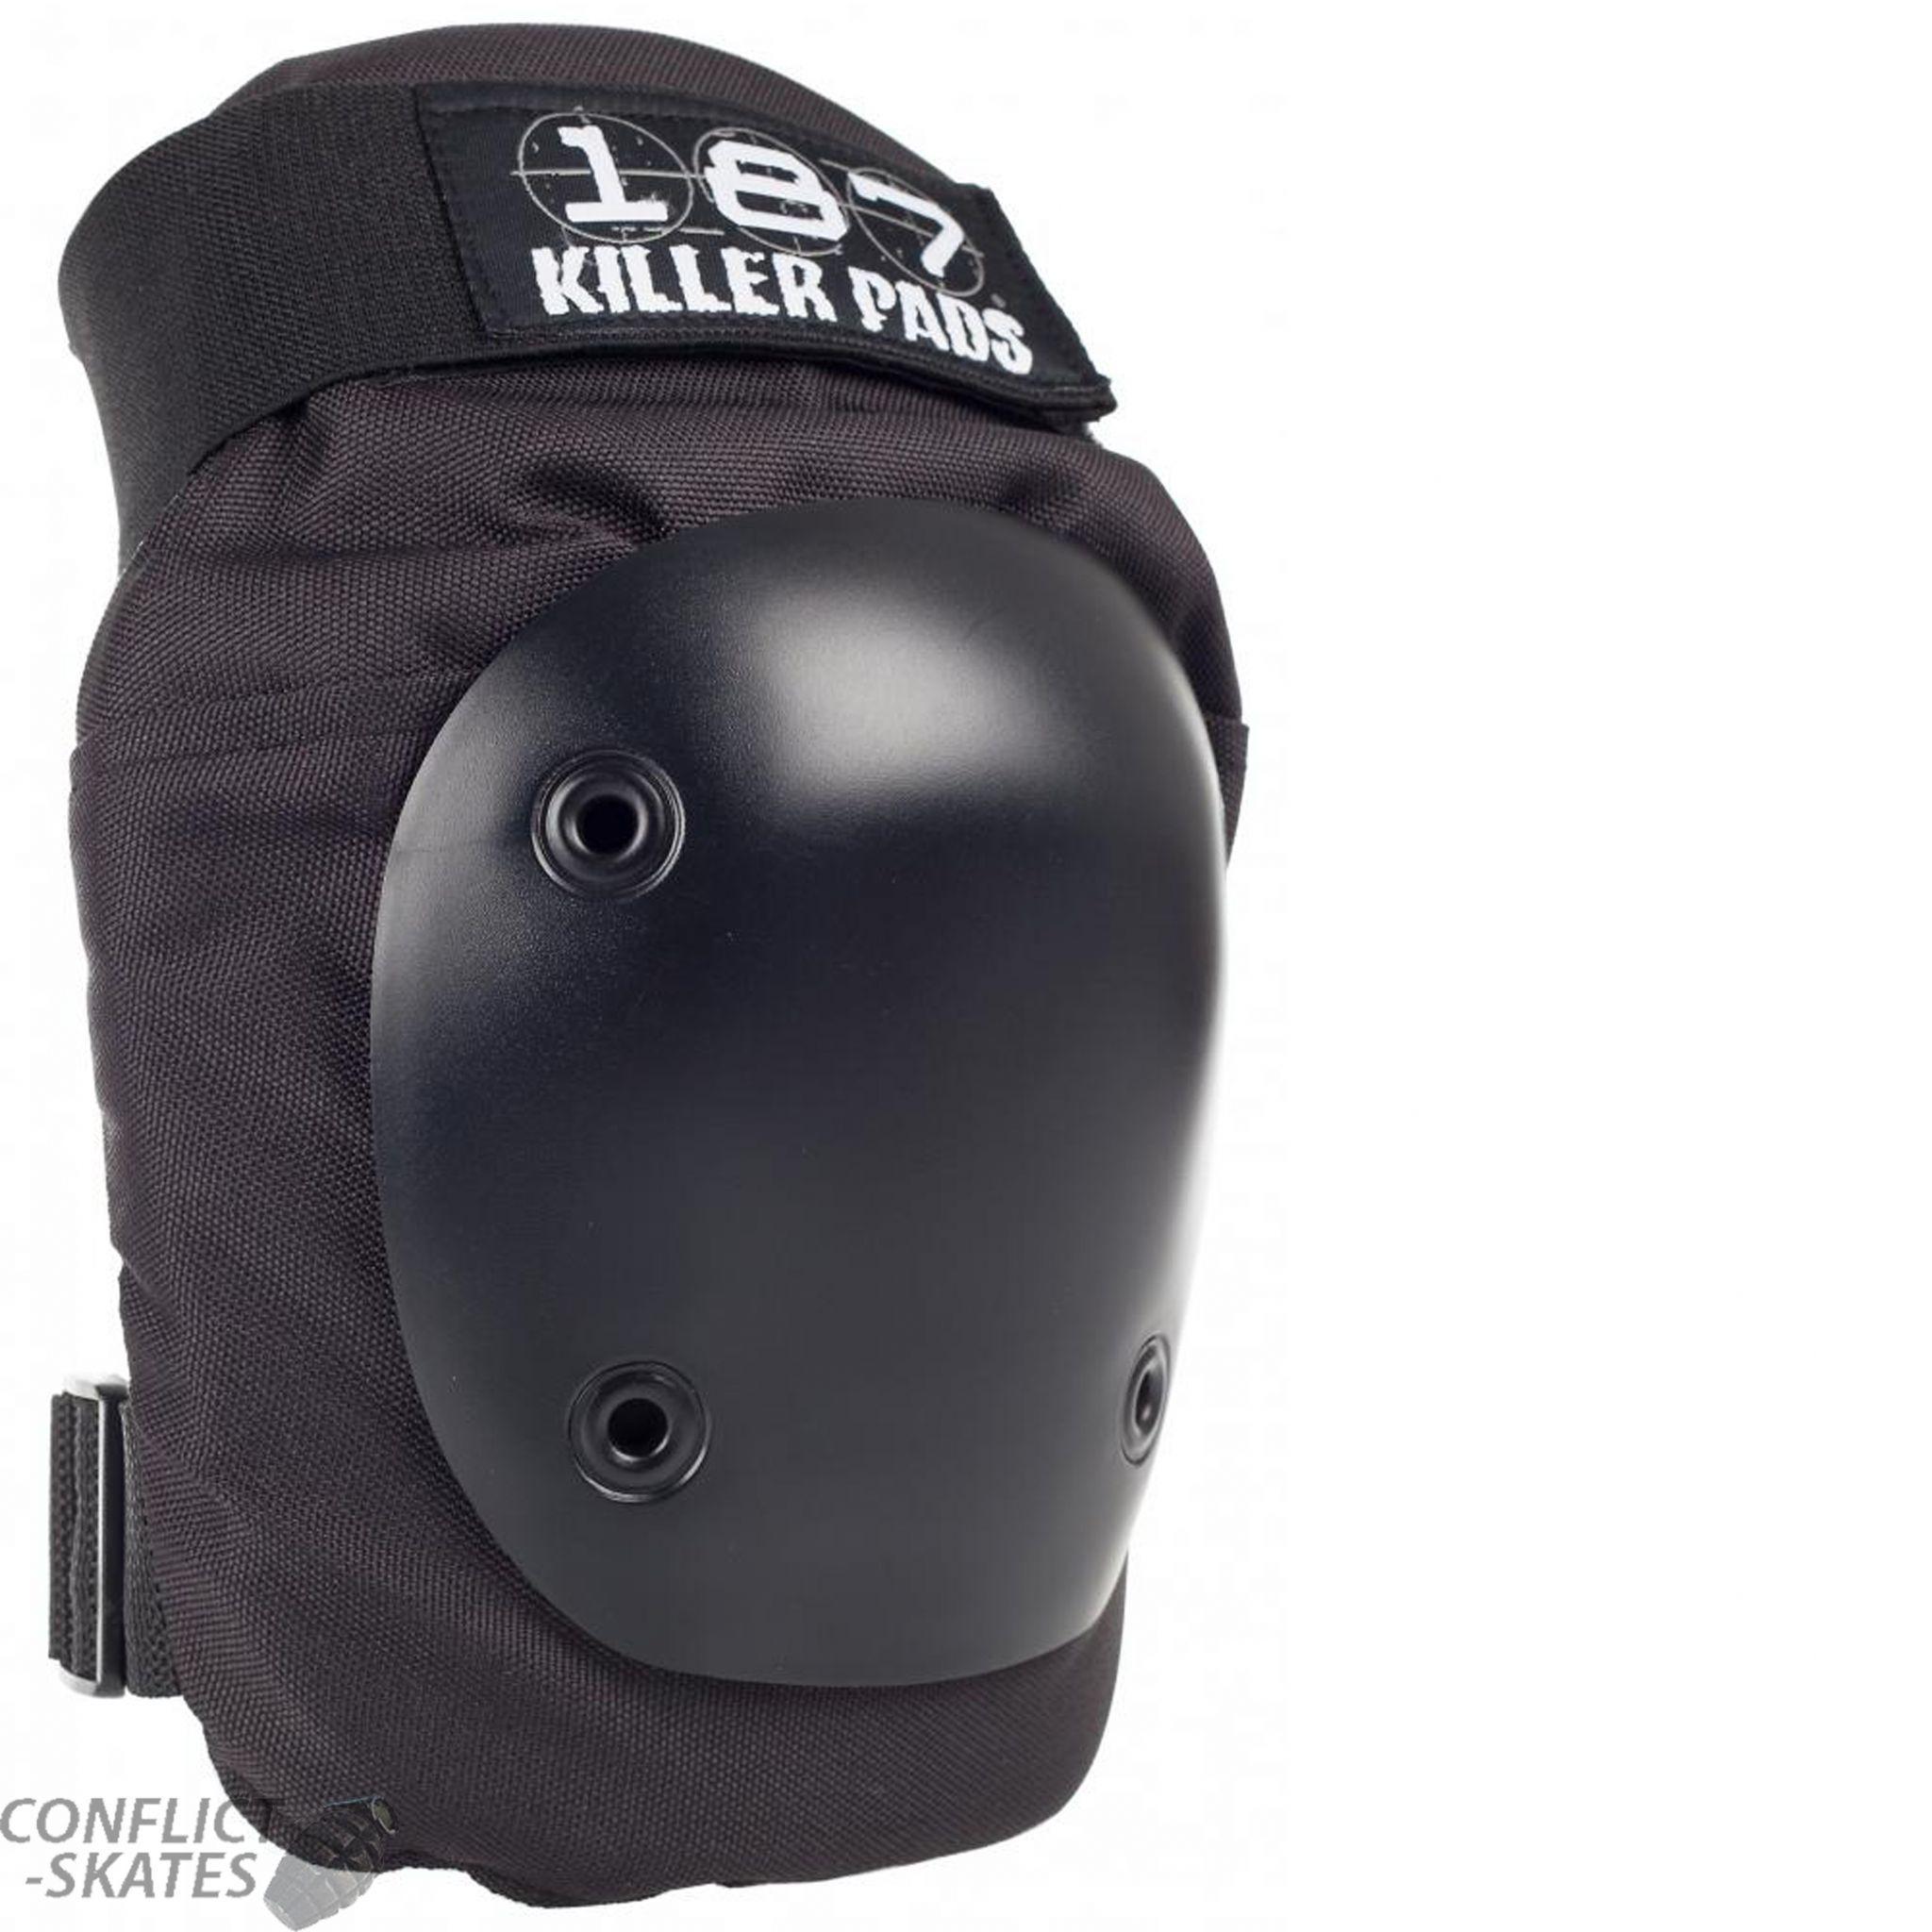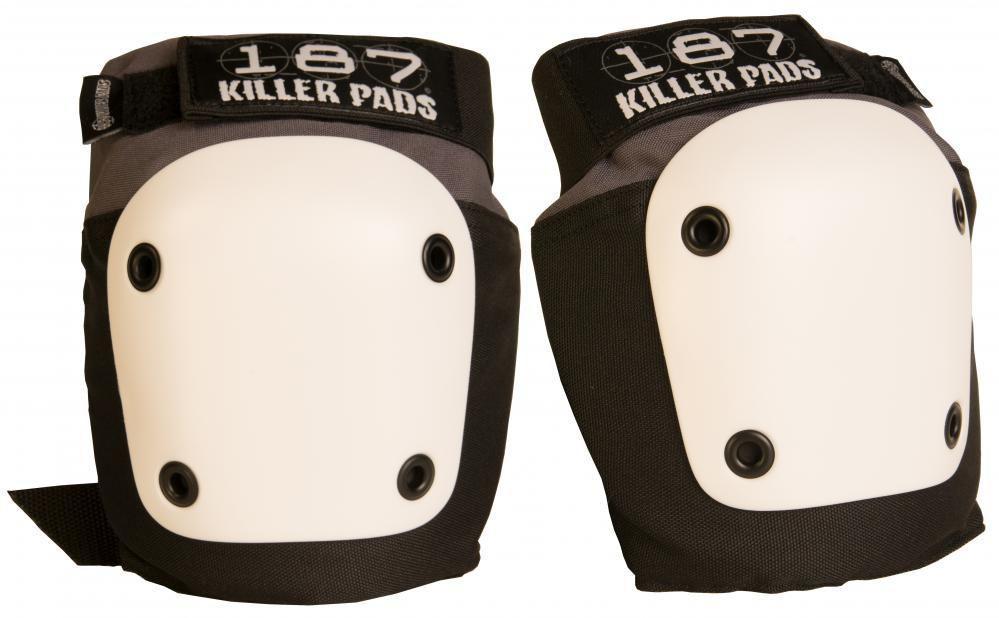The first image is the image on the left, the second image is the image on the right. Evaluate the accuracy of this statement regarding the images: "Each image contains a pair of black knee pads, and one image features a pair of knee pads with black and white print on the tops and bottoms.". Is it true? Answer yes or no. No. The first image is the image on the left, the second image is the image on the right. Given the left and right images, does the statement "One pair of pads has visible red tags, and the other pair does not." hold true? Answer yes or no. No. 